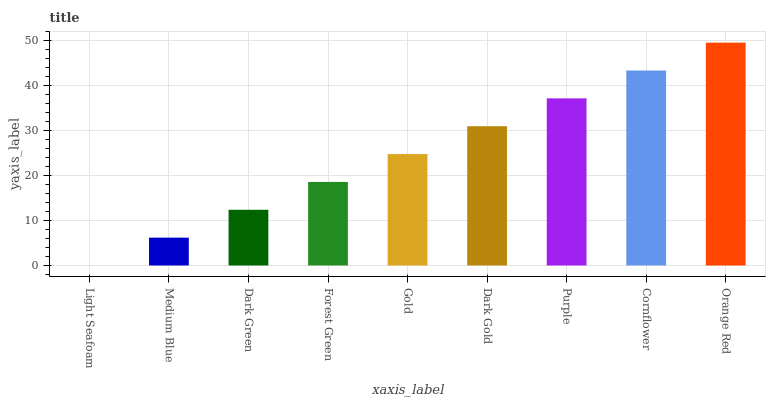Is Medium Blue the minimum?
Answer yes or no. No. Is Medium Blue the maximum?
Answer yes or no. No. Is Medium Blue greater than Light Seafoam?
Answer yes or no. Yes. Is Light Seafoam less than Medium Blue?
Answer yes or no. Yes. Is Light Seafoam greater than Medium Blue?
Answer yes or no. No. Is Medium Blue less than Light Seafoam?
Answer yes or no. No. Is Gold the high median?
Answer yes or no. Yes. Is Gold the low median?
Answer yes or no. Yes. Is Cornflower the high median?
Answer yes or no. No. Is Dark Gold the low median?
Answer yes or no. No. 